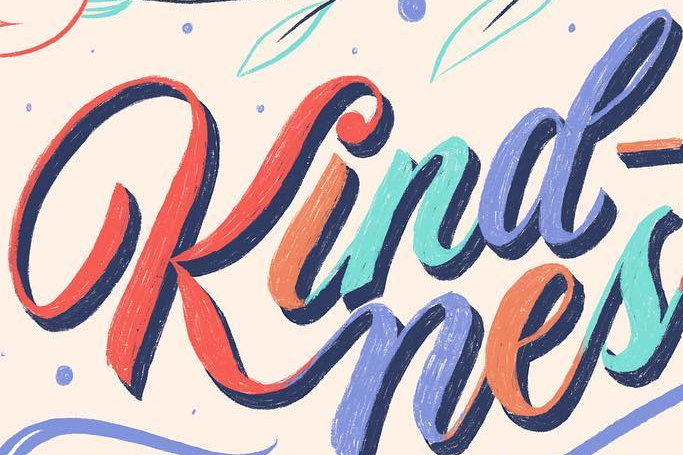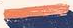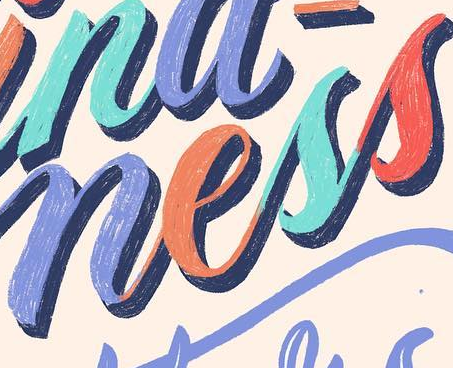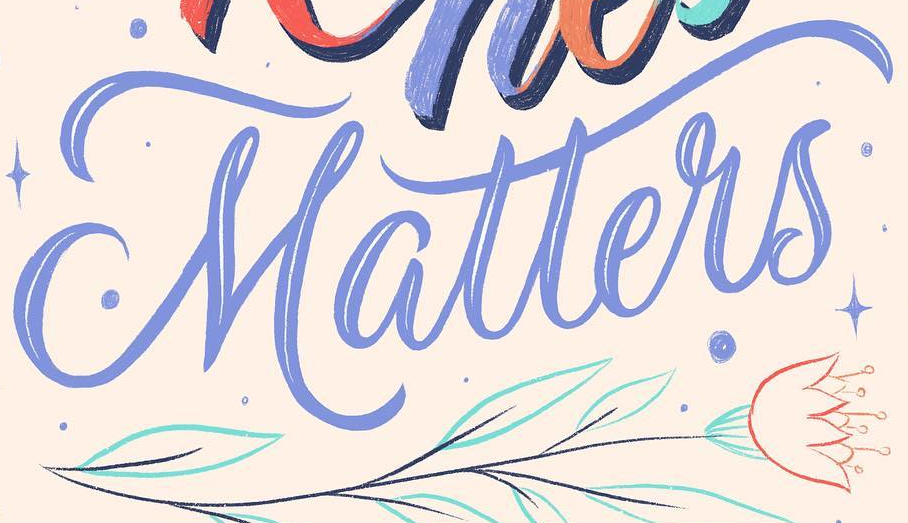What text is displayed in these images sequentially, separated by a semicolon? Kind; -; ness; Matters 